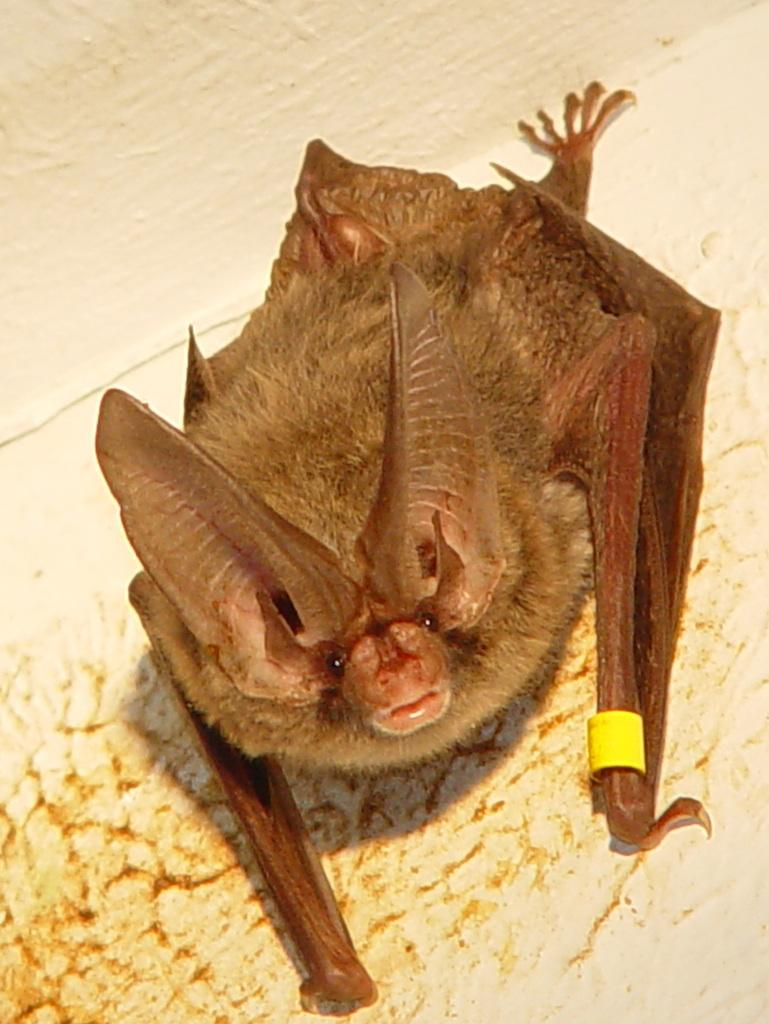What animal is present in the image? There is a bat in the image. What is the bat's current state or position? The bat is stuck to the wall. What news is the group of women discussing in the town depicted in the image? There is no group of women or town present in the image; it only features a bat stuck to the wall. 